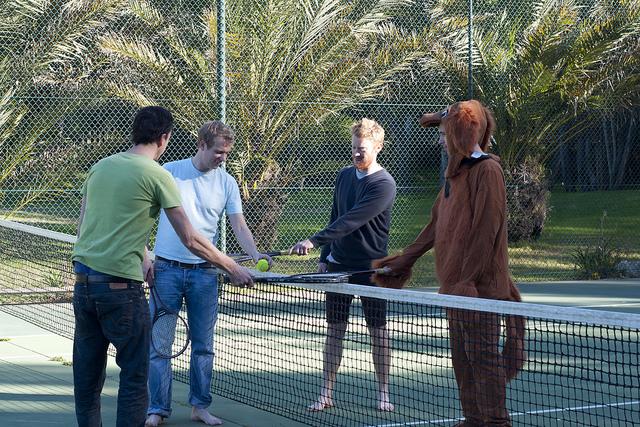Which game is played here?
Write a very short answer. Tennis. What costume is the person wearing?
Quick response, please. Dog. How many people are in this image?
Be succinct. 4. 